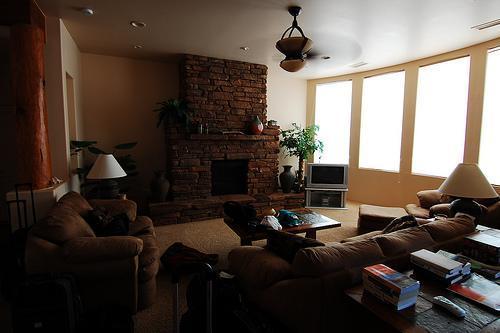How many windows?
Give a very brief answer. 4. 